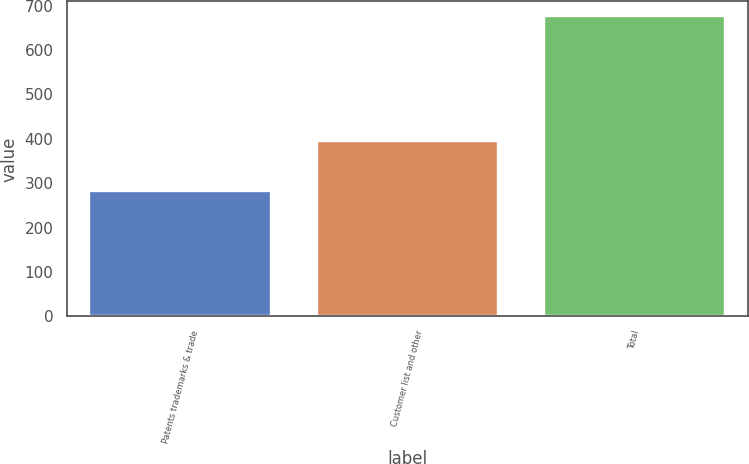Convert chart. <chart><loc_0><loc_0><loc_500><loc_500><bar_chart><fcel>Patents trademarks & trade<fcel>Customer list and other<fcel>Total<nl><fcel>282<fcel>394<fcel>676<nl></chart> 